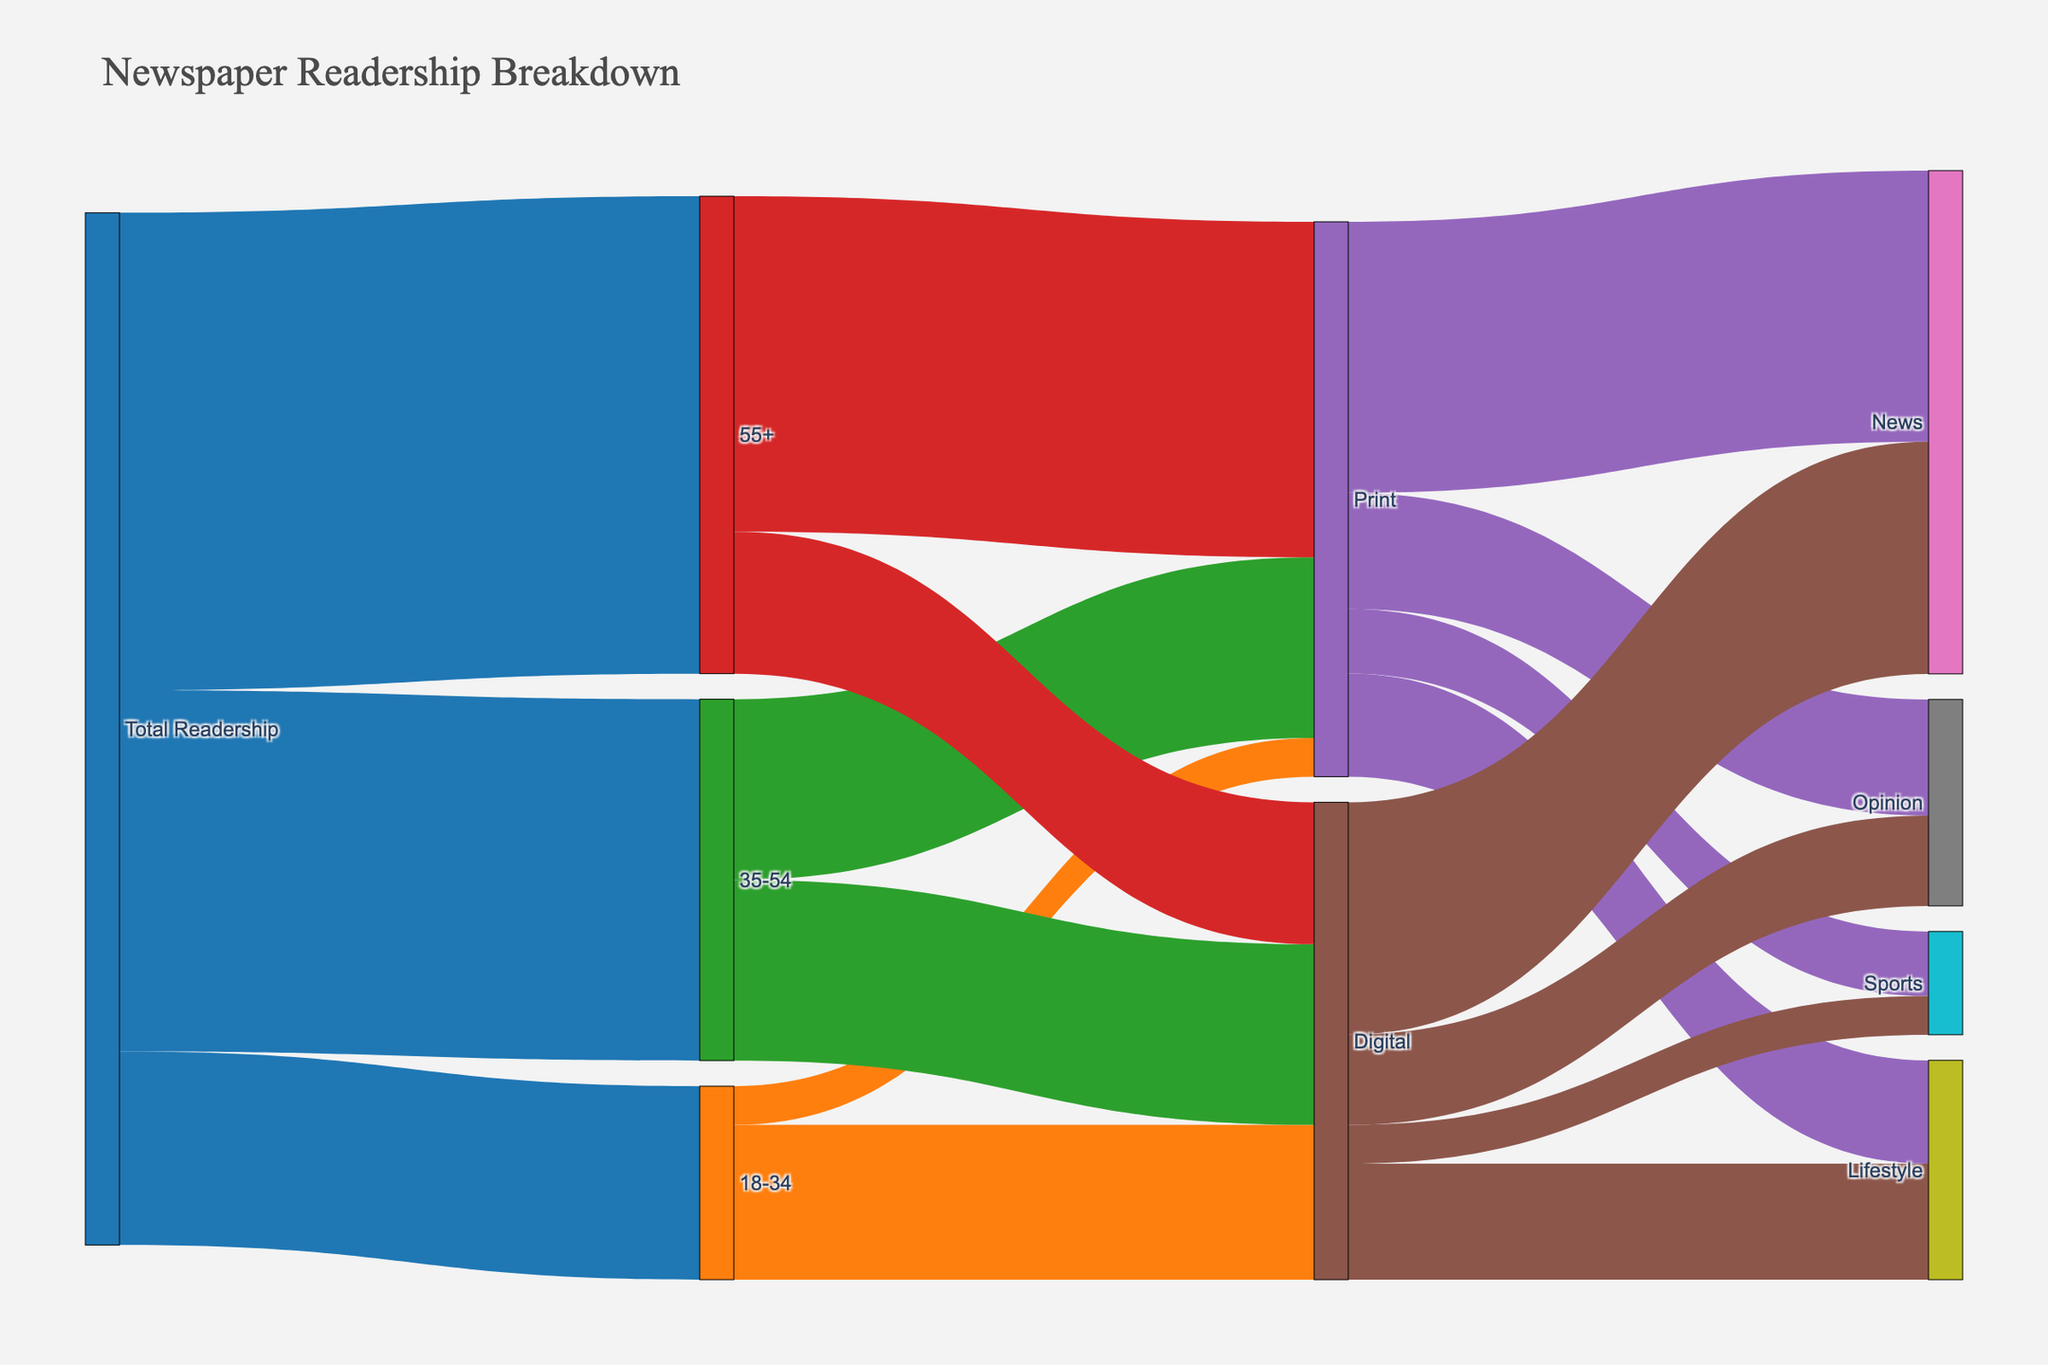What's the title of the Sankey diagram? The title of the diagram can be found at the top of the plot, which reads "Newspaper Readership Breakdown".
Answer: Newspaper Readership Breakdown What color represents the '18-34' age group? Each age group has a specific color, and the '18-34' age group is represented by the color orange.
Answer: Orange What is the total readership for the '55+' age group? The total readership for the '55+' age group is visually shown as a flow from 'Total Readership' to '55+', representing 370,000.
Answer: 370,000 How many readers in the '35-54' age group prefer Print over Digital? The flow from '35-54' to Print and Digital shows that 140,000 readers prefer Print and another 140,000 prefer Digital.
Answer: 140,000 Which content type has the highest number of readers from both Print and Digital combined? To find this, we sum up the number of readers for each content type from both Print and Digital. News has 210,000 (Print) + 180,000 (Digital) = 390,000, which is the highest.
Answer: News What is the difference in the number of Digital readers between the '18-34' and '55+' age groups? The diagram shows 120,000 Digital readers for '18-34' and 110,000 for '55+', so the difference is 120,000 - 110,000 = 10,000.
Answer: 10,000 Which content type has the least number of Print readers? Among the Print content types, the flow to Sports is the smallest, showing 50,000 readers.
Answer: Sports How many total readers prefer Lifestyle content across both Print and Digital? Summing up the Lifestyle readers from both formats: 80,000 (Print) + 90,000 (Digital) = 170,000.
Answer: 170,000 Which age group has the most significant preference for Print readership? By comparing the flows from each age group to Print, '55+' has the highest number with 260,000 readers.
Answer: 55+ What is the combined readership for 'Opinion' content in both Print and Digital formats? Opinion content has 90,000 (Print) + 70,000 (Digital) = 160,000 readers in total.
Answer: 160,000 